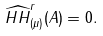<formula> <loc_0><loc_0><loc_500><loc_500>\widehat { H H } _ { ( \mu ) } ^ { r } ( A ) = 0 .</formula> 